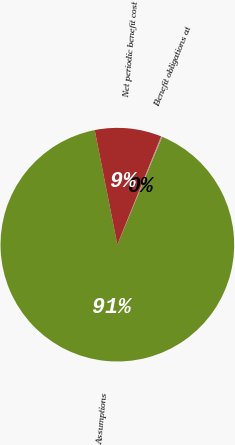Convert chart to OTSL. <chart><loc_0><loc_0><loc_500><loc_500><pie_chart><fcel>Assumptions<fcel>Benefit obligations at<fcel>Net periodic benefit cost<nl><fcel>90.64%<fcel>0.16%<fcel>9.21%<nl></chart> 